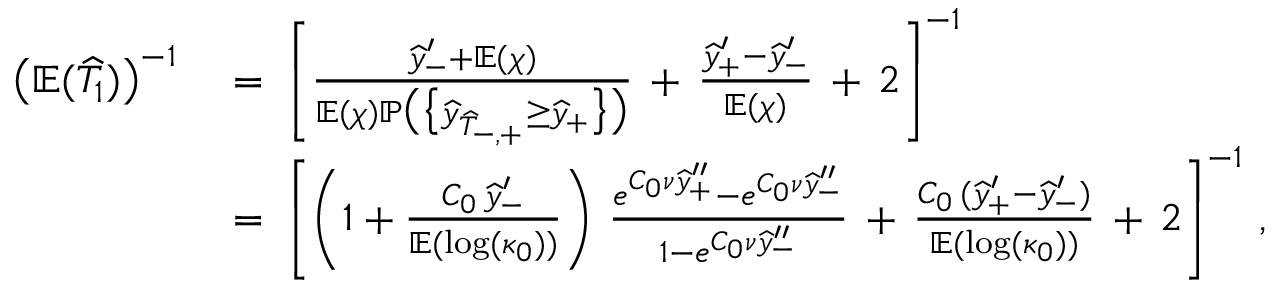Convert formula to latex. <formula><loc_0><loc_0><loc_500><loc_500>\begin{array} { r l } { \left ( \mathbb { E } ( \widehat { T } _ { 1 } ) \right ) ^ { - 1 } } & { \, = \, \left [ \frac { \widehat { y } _ { - } ^ { \prime } + \mathbb { E } ( \chi ) } { \mathbb { E } ( \chi ) \mathbb { P } \left ( \left \{ \widehat { y } _ { \widehat { T } _ { - , + } } \geq \widehat { y } _ { + } \right \} \right ) } \, + \, \frac { \widehat { y } _ { + } ^ { \prime } - \widehat { y } _ { - } ^ { \prime } } { \mathbb { E } ( \chi ) } \, + \, 2 \right ] ^ { - 1 } } \\ & { \, = \, \left [ \left ( 1 + \frac { C _ { 0 } \, \widehat { y } _ { - } ^ { \prime } } { \mathbb { E } ( \log ( \kappa _ { 0 } ) ) } \right ) \, \frac { e ^ { C _ { 0 } \nu \widehat { y } _ { + } ^ { \prime \prime } } - e ^ { C _ { 0 } \nu \widehat { y } _ { - } ^ { \prime \prime } } } { 1 - e ^ { C _ { 0 } \nu \widehat { y } _ { - } ^ { \prime \prime } } } \, + \, \frac { C _ { 0 } \, ( \widehat { y } _ { + } ^ { \prime } - \widehat { y } _ { - } ^ { \prime } ) } { \mathbb { E } ( \log ( \kappa _ { 0 } ) ) } \, + \, 2 \right ] ^ { - 1 } \, , } \end{array}</formula> 